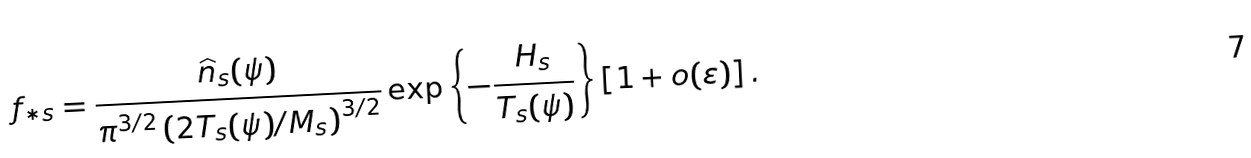Convert formula to latex. <formula><loc_0><loc_0><loc_500><loc_500>f _ { \ast s } = \frac { \widehat { n } _ { s } ( \psi ) } { \pi ^ { 3 / 2 } \left ( 2 T _ { s } ( \psi ) / M _ { s } \right ) ^ { 3 / 2 } } \exp \left \{ - \frac { H _ { s } } { T _ { s } ( \psi ) } \right \} \left [ 1 + o ( \varepsilon ) \right ] .</formula> 